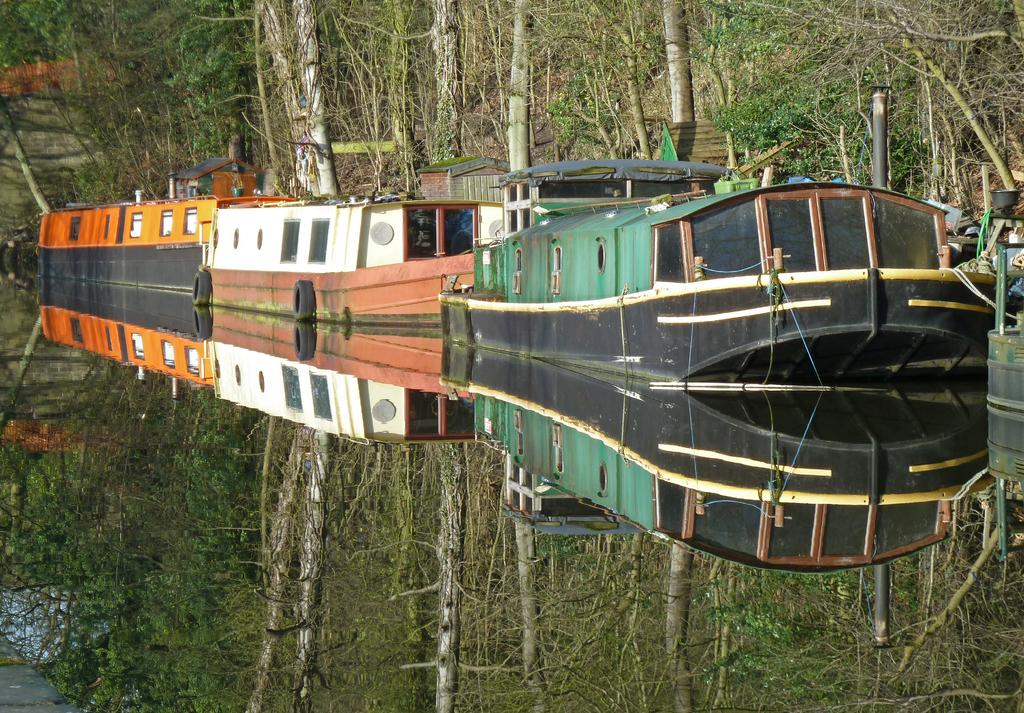What type of vehicles can be seen in the image? There are boats in the image. What type of natural elements are present in the image? There are trees in the image. What architectural feature can be seen in the image? There are stairs in the image. What type of surface is visible in the image? There is ground visible in the image. What can be observed in the water in the image? There is a reflection of trees in the water. What is located on the right side of the image? There are objects on the right side of the image. What is the time of day for the list in the image? There is no list present in the image, and therefore no time of day can be determined. What type of journey is the boat taking in the image? The image does not provide information about the boat's journey or any voyage it might be taking. 